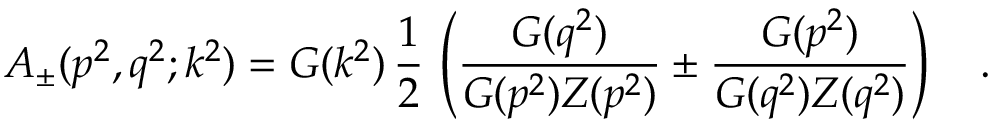<formula> <loc_0><loc_0><loc_500><loc_500>A _ { \pm } ( p ^ { 2 } , q ^ { 2 } ; k ^ { 2 } ) = G ( k ^ { 2 } ) \, \frac { 1 } { 2 } \, \left ( \frac { G ( q ^ { 2 } ) } { G ( p ^ { 2 } ) Z ( p ^ { 2 } ) } \pm \frac { G ( p ^ { 2 } ) } { G ( q ^ { 2 } ) Z ( q ^ { 2 } ) } \right ) \quad .</formula> 